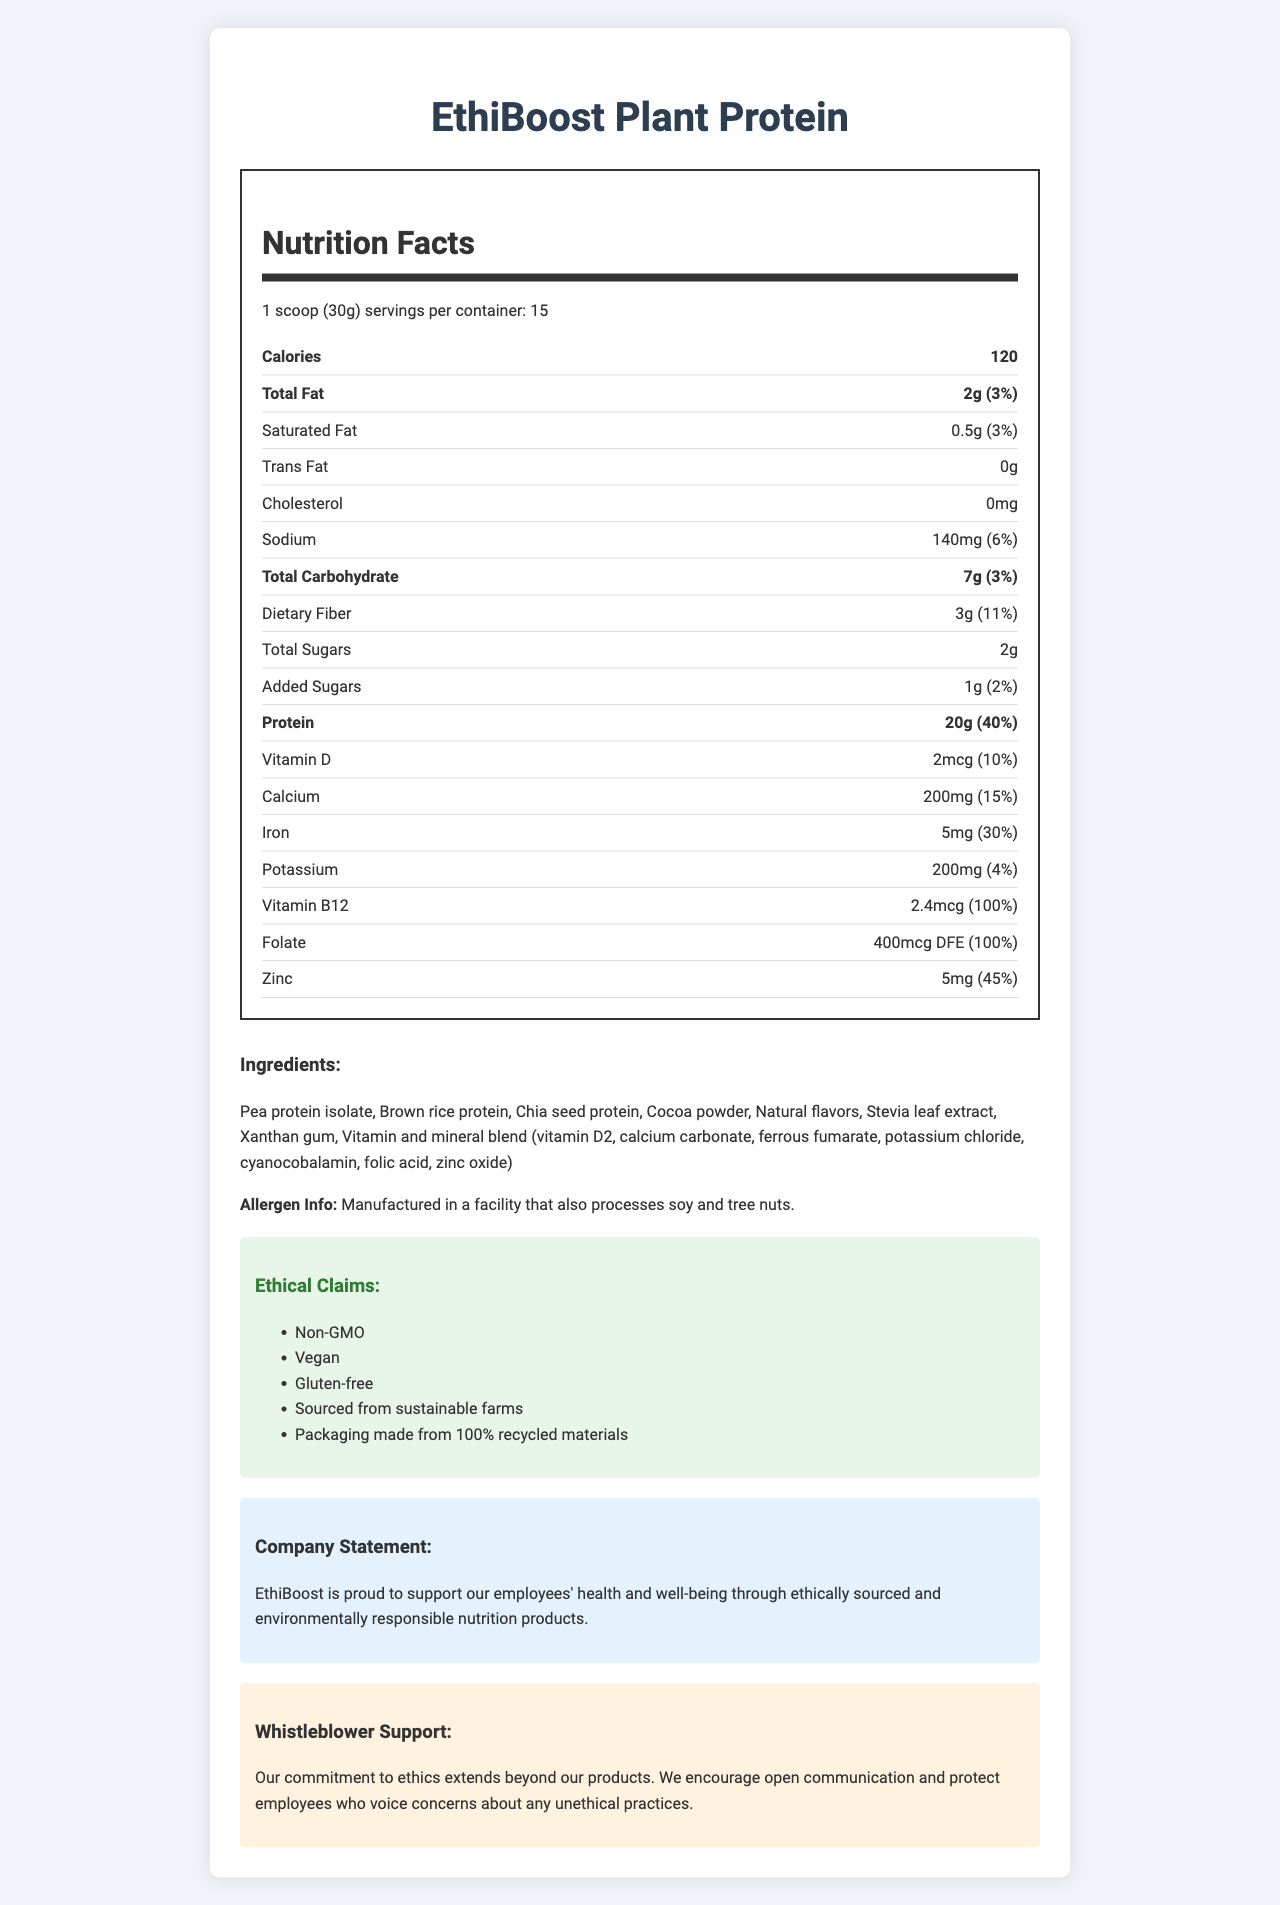what is the serving size? The serving size is mentioned at the beginning of the Nutrition Facts section.
Answer: 1 scoop (30g) how many calories are in one serving? The calorie count is clearly shown in the bold section under "Calories."
Answer: 120 calories how much protein is in one serving? The amount of protein per serving is specified under the bold "Protein" section.
Answer: 20g how much dietary fiber is in one serving? The amount of dietary fiber per serving is listed under the "Dietary Fiber" section.
Answer: 3g is the product vegan? One of the ethical claims listed under "Ethical Claims" is "Vegan."
Answer: Yes which vitamin is present at 100% daily value? A. Vitamin D B. Vitamin B12 C. Calcium D. Iron Vitamin B12 is listed with a 100% daily value in the nutrition facts section.
Answer: B. Vitamin B12 how many servings are there per container? The number of servings per container is mentioned in the Nutrition Facts section.
Answer: 15 how much iron is in one serving? A. 5mg B. 2mg C. 25mg D. 0mg The iron content is shown in the nutrition facts section under "Iron."
Answer: A. 5mg is the product gluten-free? "Gluten-free" is one of the ethical claims listed.
Answer: Yes can I consume this product if I have a soy allergy? The allergen information states that the product is manufactured in a facility that also processes soy.
Answer: Not advisable what are the main protein sources in this product? These are the first three ingredients listed under "Ingredients."
Answer: Pea protein isolate, Brown rice protein, Chia seed protein does the company support employees who voice concerns about unethical practices? The company statement and whistleblower support section confirm this support.
Answer: Yes what is the amount of folate in one serving? The amount of folate is provided in the nutrition facts section.
Answer: 400mcg DFE is there any trans fat in one serving? The nutrition facts indicate that there are 0g of trans fat per serving.
Answer: No which claim is not made by the company about this product? A. Non-GMO B. Organic C. Vegan D. Sourced from sustainable farms The ethical claims listed do not include "Organic."
Answer: B. Organic what minerals are present in one serving of this product? These minerals are listed in the nutrition facts section.
Answer: Calcium, Sodium, Iron, Potassium, Zinc describe the general message of the document. The document combines detailed nutrition facts, ingredient information, ethical claims, and reassurances about support for ethical practices in the workplace.
Answer: The document provides detailed nutritional information about EthiBoost Plant Protein, emphasizing its ethical sourcing, vegan nature, and support for employee well-being and whistleblower protection. how many calories come from fat in one serving? The document does not provide enough information to calculate the exact number of calories from fat.
Answer: Cannot be determined 